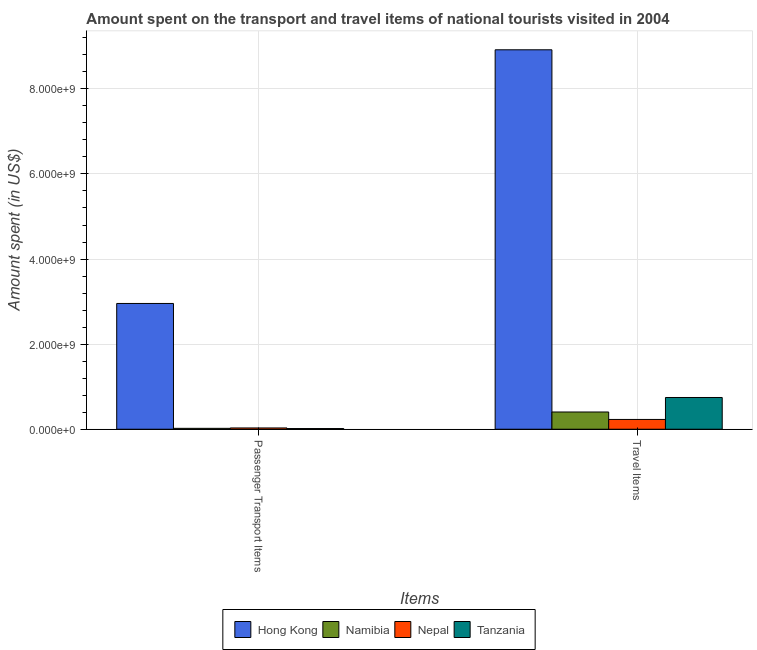How many different coloured bars are there?
Make the answer very short. 4. How many groups of bars are there?
Provide a succinct answer. 2. Are the number of bars on each tick of the X-axis equal?
Give a very brief answer. Yes. How many bars are there on the 2nd tick from the left?
Offer a terse response. 4. What is the label of the 2nd group of bars from the left?
Make the answer very short. Travel Items. What is the amount spent on passenger transport items in Tanzania?
Make the answer very short. 1.60e+07. Across all countries, what is the maximum amount spent on passenger transport items?
Ensure brevity in your answer.  2.96e+09. Across all countries, what is the minimum amount spent in travel items?
Provide a succinct answer. 2.30e+08. In which country was the amount spent in travel items maximum?
Your answer should be very brief. Hong Kong. In which country was the amount spent in travel items minimum?
Give a very brief answer. Nepal. What is the total amount spent on passenger transport items in the graph?
Provide a succinct answer. 3.02e+09. What is the difference between the amount spent in travel items in Tanzania and that in Nepal?
Your answer should be very brief. 5.16e+08. What is the difference between the amount spent on passenger transport items in Hong Kong and the amount spent in travel items in Nepal?
Ensure brevity in your answer.  2.73e+09. What is the average amount spent in travel items per country?
Make the answer very short. 2.57e+09. What is the difference between the amount spent on passenger transport items and amount spent in travel items in Namibia?
Ensure brevity in your answer.  -3.84e+08. In how many countries, is the amount spent in travel items greater than 400000000 US$?
Give a very brief answer. 3. What is the ratio of the amount spent in travel items in Hong Kong to that in Tanzania?
Keep it short and to the point. 11.95. Is the amount spent on passenger transport items in Nepal less than that in Tanzania?
Your answer should be very brief. No. In how many countries, is the amount spent on passenger transport items greater than the average amount spent on passenger transport items taken over all countries?
Offer a terse response. 1. What does the 3rd bar from the left in Passenger Transport Items represents?
Your response must be concise. Nepal. What does the 4th bar from the right in Travel Items represents?
Your answer should be very brief. Hong Kong. Are all the bars in the graph horizontal?
Your response must be concise. No. What is the difference between two consecutive major ticks on the Y-axis?
Offer a very short reply. 2.00e+09. Where does the legend appear in the graph?
Your answer should be compact. Bottom center. What is the title of the graph?
Make the answer very short. Amount spent on the transport and travel items of national tourists visited in 2004. Does "Czech Republic" appear as one of the legend labels in the graph?
Offer a very short reply. No. What is the label or title of the X-axis?
Ensure brevity in your answer.  Items. What is the label or title of the Y-axis?
Keep it short and to the point. Amount spent (in US$). What is the Amount spent (in US$) of Hong Kong in Passenger Transport Items?
Offer a very short reply. 2.96e+09. What is the Amount spent (in US$) in Namibia in Passenger Transport Items?
Keep it short and to the point. 2.10e+07. What is the Amount spent (in US$) in Nepal in Passenger Transport Items?
Give a very brief answer. 3.00e+07. What is the Amount spent (in US$) of Tanzania in Passenger Transport Items?
Your answer should be very brief. 1.60e+07. What is the Amount spent (in US$) of Hong Kong in Travel Items?
Ensure brevity in your answer.  8.92e+09. What is the Amount spent (in US$) in Namibia in Travel Items?
Offer a terse response. 4.05e+08. What is the Amount spent (in US$) of Nepal in Travel Items?
Your response must be concise. 2.30e+08. What is the Amount spent (in US$) of Tanzania in Travel Items?
Offer a terse response. 7.46e+08. Across all Items, what is the maximum Amount spent (in US$) in Hong Kong?
Make the answer very short. 8.92e+09. Across all Items, what is the maximum Amount spent (in US$) in Namibia?
Your answer should be very brief. 4.05e+08. Across all Items, what is the maximum Amount spent (in US$) of Nepal?
Provide a short and direct response. 2.30e+08. Across all Items, what is the maximum Amount spent (in US$) in Tanzania?
Offer a very short reply. 7.46e+08. Across all Items, what is the minimum Amount spent (in US$) in Hong Kong?
Your answer should be very brief. 2.96e+09. Across all Items, what is the minimum Amount spent (in US$) in Namibia?
Your response must be concise. 2.10e+07. Across all Items, what is the minimum Amount spent (in US$) of Nepal?
Give a very brief answer. 3.00e+07. Across all Items, what is the minimum Amount spent (in US$) of Tanzania?
Give a very brief answer. 1.60e+07. What is the total Amount spent (in US$) of Hong Kong in the graph?
Offer a very short reply. 1.19e+1. What is the total Amount spent (in US$) in Namibia in the graph?
Provide a short and direct response. 4.26e+08. What is the total Amount spent (in US$) in Nepal in the graph?
Give a very brief answer. 2.60e+08. What is the total Amount spent (in US$) of Tanzania in the graph?
Ensure brevity in your answer.  7.62e+08. What is the difference between the Amount spent (in US$) of Hong Kong in Passenger Transport Items and that in Travel Items?
Offer a very short reply. -5.96e+09. What is the difference between the Amount spent (in US$) in Namibia in Passenger Transport Items and that in Travel Items?
Offer a terse response. -3.84e+08. What is the difference between the Amount spent (in US$) in Nepal in Passenger Transport Items and that in Travel Items?
Keep it short and to the point. -2.00e+08. What is the difference between the Amount spent (in US$) of Tanzania in Passenger Transport Items and that in Travel Items?
Offer a terse response. -7.30e+08. What is the difference between the Amount spent (in US$) of Hong Kong in Passenger Transport Items and the Amount spent (in US$) of Namibia in Travel Items?
Make the answer very short. 2.55e+09. What is the difference between the Amount spent (in US$) in Hong Kong in Passenger Transport Items and the Amount spent (in US$) in Nepal in Travel Items?
Offer a terse response. 2.73e+09. What is the difference between the Amount spent (in US$) in Hong Kong in Passenger Transport Items and the Amount spent (in US$) in Tanzania in Travel Items?
Make the answer very short. 2.21e+09. What is the difference between the Amount spent (in US$) of Namibia in Passenger Transport Items and the Amount spent (in US$) of Nepal in Travel Items?
Ensure brevity in your answer.  -2.09e+08. What is the difference between the Amount spent (in US$) of Namibia in Passenger Transport Items and the Amount spent (in US$) of Tanzania in Travel Items?
Keep it short and to the point. -7.25e+08. What is the difference between the Amount spent (in US$) in Nepal in Passenger Transport Items and the Amount spent (in US$) in Tanzania in Travel Items?
Offer a terse response. -7.16e+08. What is the average Amount spent (in US$) of Hong Kong per Items?
Your response must be concise. 5.94e+09. What is the average Amount spent (in US$) in Namibia per Items?
Keep it short and to the point. 2.13e+08. What is the average Amount spent (in US$) in Nepal per Items?
Provide a short and direct response. 1.30e+08. What is the average Amount spent (in US$) in Tanzania per Items?
Ensure brevity in your answer.  3.81e+08. What is the difference between the Amount spent (in US$) of Hong Kong and Amount spent (in US$) of Namibia in Passenger Transport Items?
Your answer should be compact. 2.94e+09. What is the difference between the Amount spent (in US$) in Hong Kong and Amount spent (in US$) in Nepal in Passenger Transport Items?
Provide a short and direct response. 2.93e+09. What is the difference between the Amount spent (in US$) of Hong Kong and Amount spent (in US$) of Tanzania in Passenger Transport Items?
Your response must be concise. 2.94e+09. What is the difference between the Amount spent (in US$) of Namibia and Amount spent (in US$) of Nepal in Passenger Transport Items?
Provide a short and direct response. -9.00e+06. What is the difference between the Amount spent (in US$) of Namibia and Amount spent (in US$) of Tanzania in Passenger Transport Items?
Ensure brevity in your answer.  5.00e+06. What is the difference between the Amount spent (in US$) of Nepal and Amount spent (in US$) of Tanzania in Passenger Transport Items?
Your response must be concise. 1.40e+07. What is the difference between the Amount spent (in US$) in Hong Kong and Amount spent (in US$) in Namibia in Travel Items?
Provide a succinct answer. 8.51e+09. What is the difference between the Amount spent (in US$) of Hong Kong and Amount spent (in US$) of Nepal in Travel Items?
Your response must be concise. 8.69e+09. What is the difference between the Amount spent (in US$) in Hong Kong and Amount spent (in US$) in Tanzania in Travel Items?
Keep it short and to the point. 8.17e+09. What is the difference between the Amount spent (in US$) in Namibia and Amount spent (in US$) in Nepal in Travel Items?
Ensure brevity in your answer.  1.75e+08. What is the difference between the Amount spent (in US$) in Namibia and Amount spent (in US$) in Tanzania in Travel Items?
Provide a succinct answer. -3.41e+08. What is the difference between the Amount spent (in US$) of Nepal and Amount spent (in US$) of Tanzania in Travel Items?
Provide a short and direct response. -5.16e+08. What is the ratio of the Amount spent (in US$) of Hong Kong in Passenger Transport Items to that in Travel Items?
Keep it short and to the point. 0.33. What is the ratio of the Amount spent (in US$) of Namibia in Passenger Transport Items to that in Travel Items?
Your response must be concise. 0.05. What is the ratio of the Amount spent (in US$) of Nepal in Passenger Transport Items to that in Travel Items?
Offer a very short reply. 0.13. What is the ratio of the Amount spent (in US$) in Tanzania in Passenger Transport Items to that in Travel Items?
Your answer should be very brief. 0.02. What is the difference between the highest and the second highest Amount spent (in US$) in Hong Kong?
Offer a very short reply. 5.96e+09. What is the difference between the highest and the second highest Amount spent (in US$) of Namibia?
Offer a very short reply. 3.84e+08. What is the difference between the highest and the second highest Amount spent (in US$) in Tanzania?
Keep it short and to the point. 7.30e+08. What is the difference between the highest and the lowest Amount spent (in US$) in Hong Kong?
Provide a succinct answer. 5.96e+09. What is the difference between the highest and the lowest Amount spent (in US$) in Namibia?
Give a very brief answer. 3.84e+08. What is the difference between the highest and the lowest Amount spent (in US$) in Tanzania?
Offer a very short reply. 7.30e+08. 